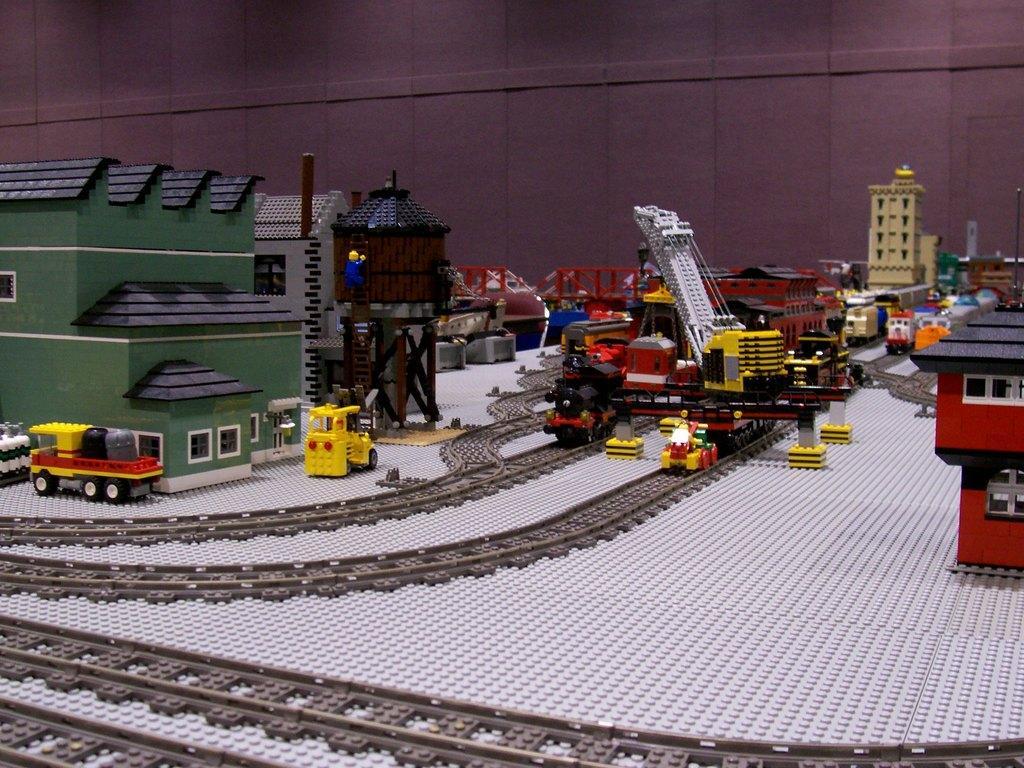Describe this image in one or two sentences. In this image, we can see some toys like houses, vehicles, a bridge and railway tracks. We can also see the ground. We can see the wall. 